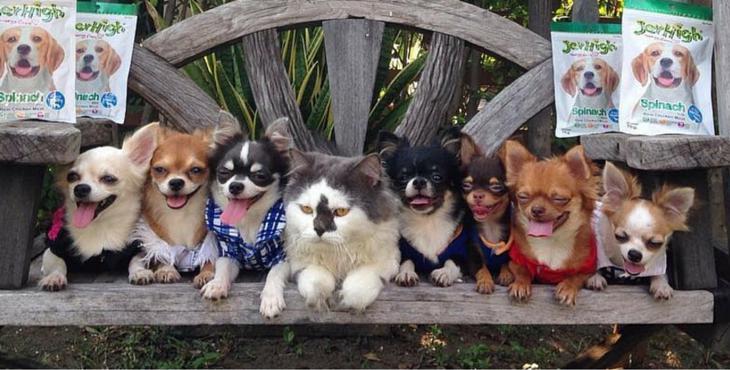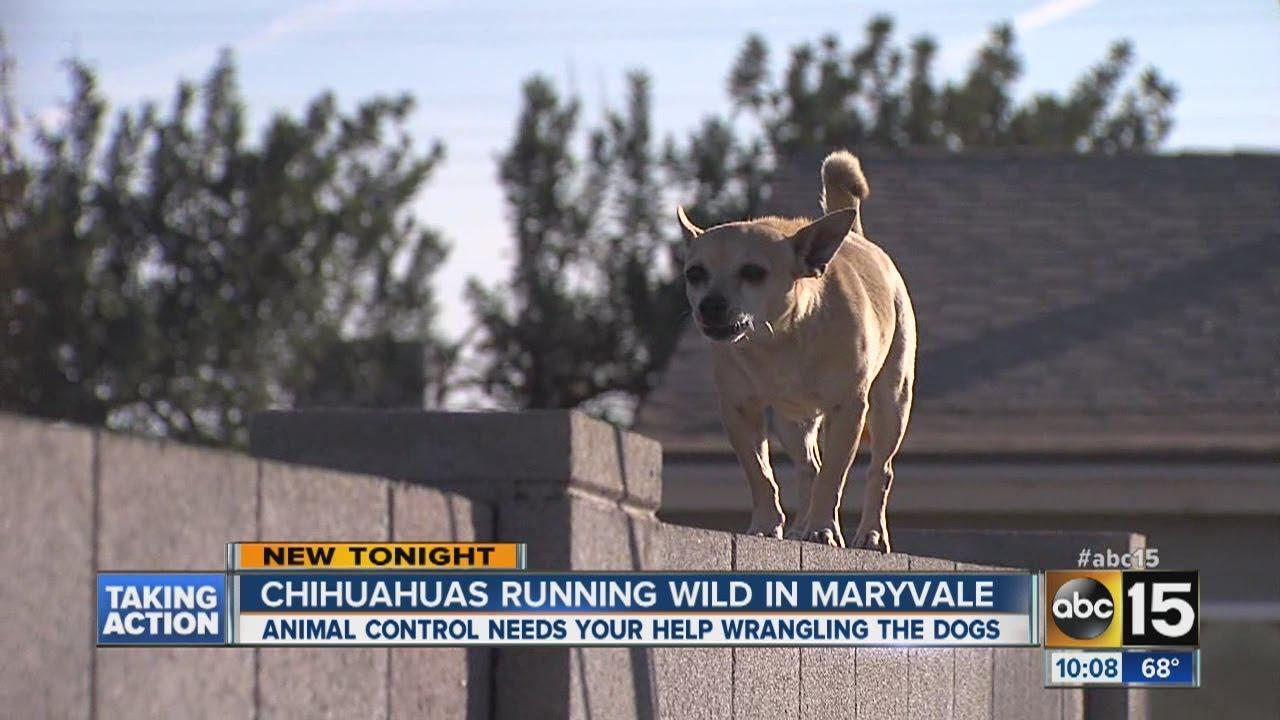The first image is the image on the left, the second image is the image on the right. For the images displayed, is the sentence "In at least one image, there is only one dog." factually correct? Answer yes or no. Yes. The first image is the image on the left, the second image is the image on the right. Assess this claim about the two images: "At least one of the images contains only one chihuahuas.". Correct or not? Answer yes or no. Yes. 